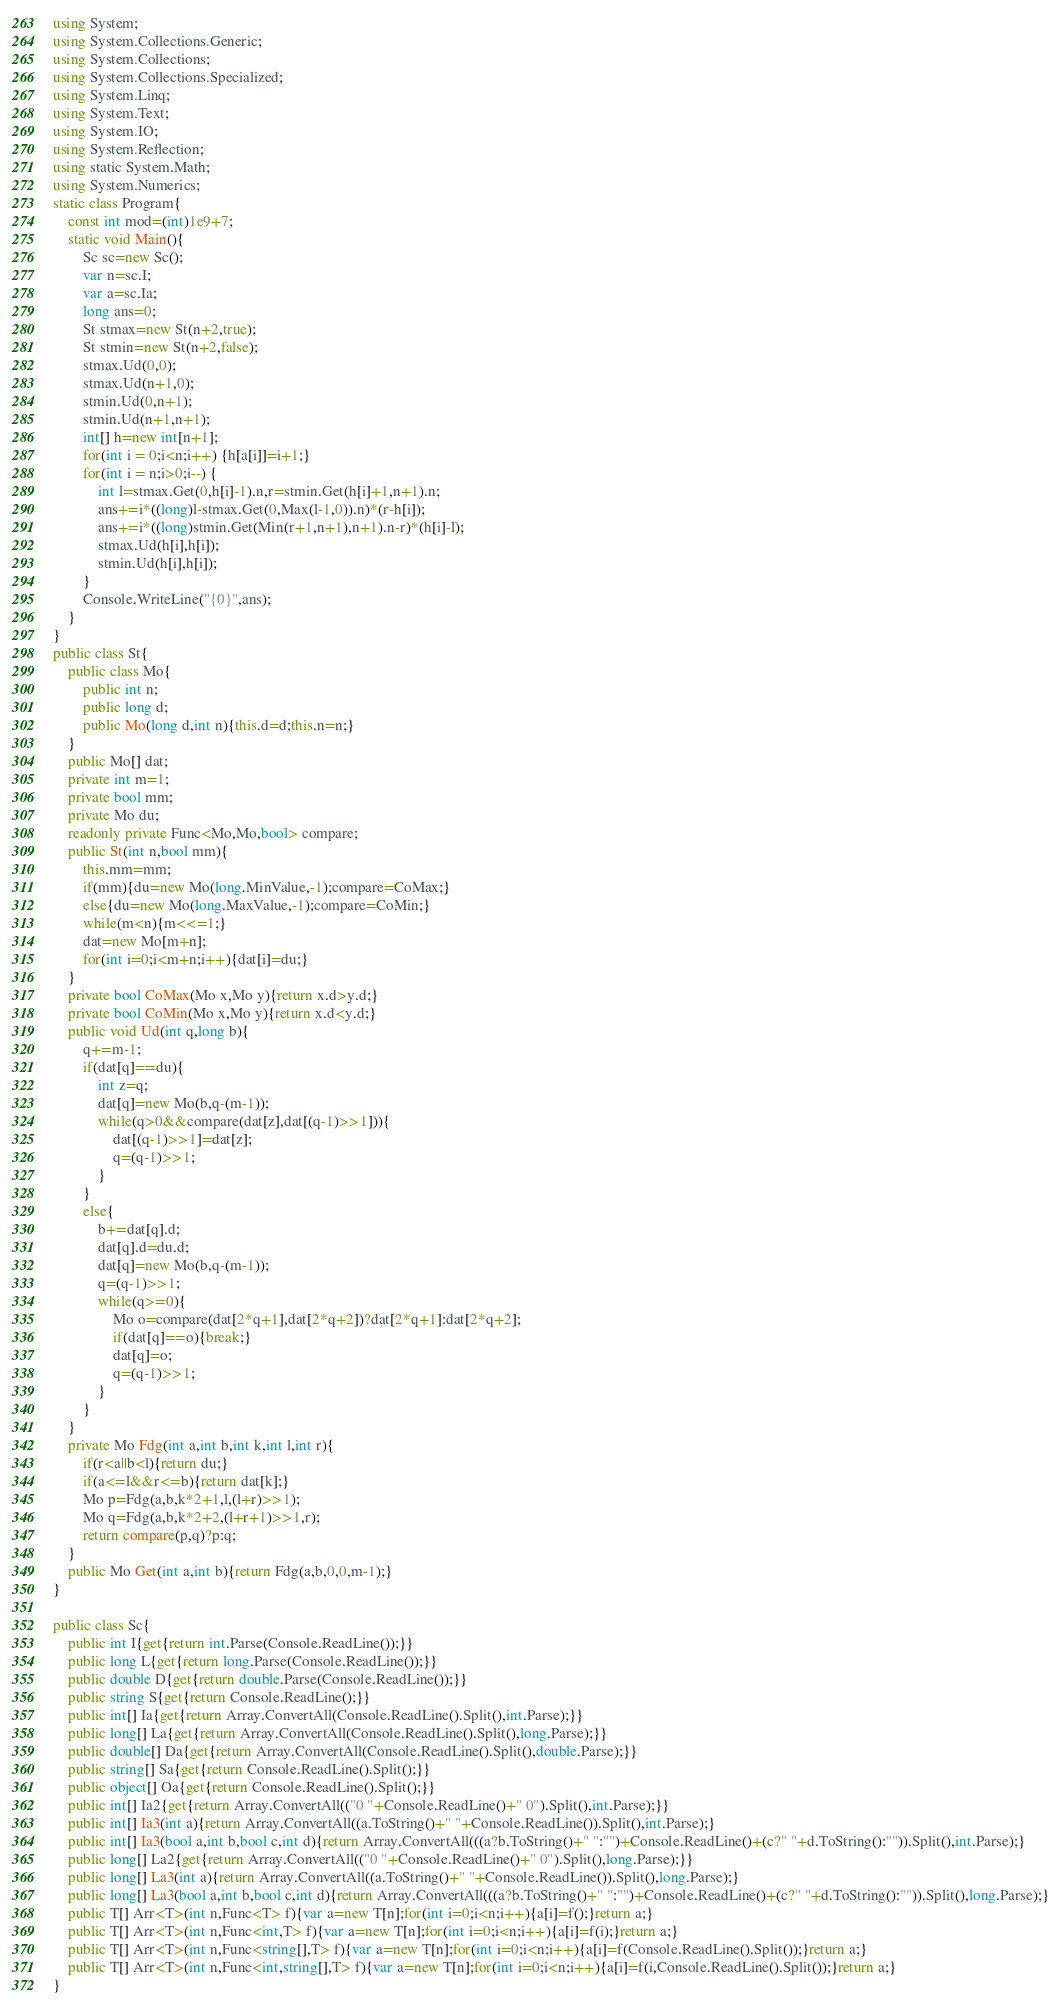<code> <loc_0><loc_0><loc_500><loc_500><_C#_>using System;
using System.Collections.Generic;
using System.Collections;
using System.Collections.Specialized;
using System.Linq;
using System.Text;
using System.IO;
using System.Reflection;
using static System.Math;
using System.Numerics;
static class Program{
	const int mod=(int)1e9+7;
	static void Main(){
		Sc sc=new Sc();
		var n=sc.I;
		var a=sc.Ia;
		long ans=0;
		St stmax=new St(n+2,true);
		St stmin=new St(n+2,false);
		stmax.Ud(0,0);
		stmax.Ud(n+1,0);
		stmin.Ud(0,n+1);
		stmin.Ud(n+1,n+1);
		int[] h=new int[n+1];
		for(int i = 0;i<n;i++) {h[a[i]]=i+1;}
		for(int i = n;i>0;i--) {
			int l=stmax.Get(0,h[i]-1).n,r=stmin.Get(h[i]+1,n+1).n;
			ans+=i*((long)l-stmax.Get(0,Max(l-1,0)).n)*(r-h[i]);
			ans+=i*((long)stmin.Get(Min(r+1,n+1),n+1).n-r)*(h[i]-l);
			stmax.Ud(h[i],h[i]);
			stmin.Ud(h[i],h[i]);
		}
		Console.WriteLine("{0}",ans);
	}
}
public class St{
	public class Mo{
		public int n;
		public long d;
		public Mo(long d,int n){this.d=d;this.n=n;}
	}
	public Mo[] dat;
	private int m=1;
	private bool mm;
	private Mo du;
	readonly private Func<Mo,Mo,bool> compare;
	public St(int n,bool mm){
		this.mm=mm;
		if(mm){du=new Mo(long.MinValue,-1);compare=CoMax;}
		else{du=new Mo(long.MaxValue,-1);compare=CoMin;}
		while(m<n){m<<=1;}
		dat=new Mo[m+n];
		for(int i=0;i<m+n;i++){dat[i]=du;}
	}
	private bool CoMax(Mo x,Mo y){return x.d>y.d;}
	private bool CoMin(Mo x,Mo y){return x.d<y.d;}
	public void Ud(int q,long b){
		q+=m-1;
		if(dat[q]==du){
			int z=q;
			dat[q]=new Mo(b,q-(m-1));
			while(q>0&&compare(dat[z],dat[(q-1)>>1])){
				dat[(q-1)>>1]=dat[z];
				q=(q-1)>>1;
			}
		}
		else{
			b+=dat[q].d;
			dat[q].d=du.d;
			dat[q]=new Mo(b,q-(m-1));
			q=(q-1)>>1;
			while(q>=0){
				Mo o=compare(dat[2*q+1],dat[2*q+2])?dat[2*q+1]:dat[2*q+2];
				if(dat[q]==o){break;}
				dat[q]=o;
				q=(q-1)>>1;
			}
		}
	}
	private Mo Fdg(int a,int b,int k,int l,int r){
		if(r<a||b<l){return du;}
		if(a<=l&&r<=b){return dat[k];}
		Mo p=Fdg(a,b,k*2+1,l,(l+r)>>1);
		Mo q=Fdg(a,b,k*2+2,(l+r+1)>>1,r);
		return compare(p,q)?p:q;
	}
	public Mo Get(int a,int b){return Fdg(a,b,0,0,m-1);}
}

public class Sc{
	public int I{get{return int.Parse(Console.ReadLine());}}
	public long L{get{return long.Parse(Console.ReadLine());}}
	public double D{get{return double.Parse(Console.ReadLine());}}
	public string S{get{return Console.ReadLine();}}
	public int[] Ia{get{return Array.ConvertAll(Console.ReadLine().Split(),int.Parse);}}
	public long[] La{get{return Array.ConvertAll(Console.ReadLine().Split(),long.Parse);}}
	public double[] Da{get{return Array.ConvertAll(Console.ReadLine().Split(),double.Parse);}}
	public string[] Sa{get{return Console.ReadLine().Split();}}
	public object[] Oa{get{return Console.ReadLine().Split();}}
	public int[] Ia2{get{return Array.ConvertAll(("0 "+Console.ReadLine()+" 0").Split(),int.Parse);}}
	public int[] Ia3(int a){return Array.ConvertAll((a.ToString()+" "+Console.ReadLine()).Split(),int.Parse);}
	public int[] Ia3(bool a,int b,bool c,int d){return Array.ConvertAll(((a?b.ToString()+" ":"")+Console.ReadLine()+(c?" "+d.ToString():"")).Split(),int.Parse);}
	public long[] La2{get{return Array.ConvertAll(("0 "+Console.ReadLine()+" 0").Split(),long.Parse);}}
	public long[] La3(int a){return Array.ConvertAll((a.ToString()+" "+Console.ReadLine()).Split(),long.Parse);}
	public long[] La3(bool a,int b,bool c,int d){return Array.ConvertAll(((a?b.ToString()+" ":"")+Console.ReadLine()+(c?" "+d.ToString():"")).Split(),long.Parse);}
	public T[] Arr<T>(int n,Func<T> f){var a=new T[n];for(int i=0;i<n;i++){a[i]=f();}return a;}
	public T[] Arr<T>(int n,Func<int,T> f){var a=new T[n];for(int i=0;i<n;i++){a[i]=f(i);}return a;}
	public T[] Arr<T>(int n,Func<string[],T> f){var a=new T[n];for(int i=0;i<n;i++){a[i]=f(Console.ReadLine().Split());}return a;}
	public T[] Arr<T>(int n,Func<int,string[],T> f){var a=new T[n];for(int i=0;i<n;i++){a[i]=f(i,Console.ReadLine().Split());}return a;}
}</code> 